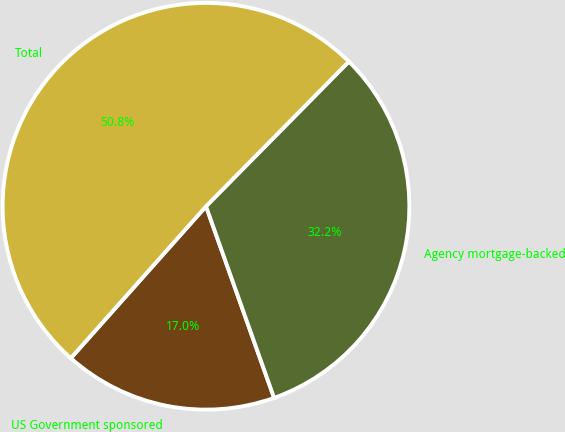Convert chart. <chart><loc_0><loc_0><loc_500><loc_500><pie_chart><fcel>US Government sponsored<fcel>Agency mortgage-backed<fcel>Total<nl><fcel>17.01%<fcel>32.17%<fcel>50.82%<nl></chart> 